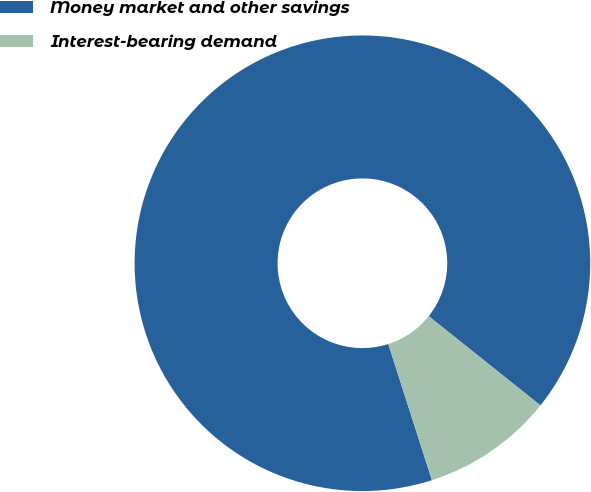Convert chart to OTSL. <chart><loc_0><loc_0><loc_500><loc_500><pie_chart><fcel>Money market and other savings<fcel>Interest-bearing demand<nl><fcel>90.66%<fcel>9.34%<nl></chart> 